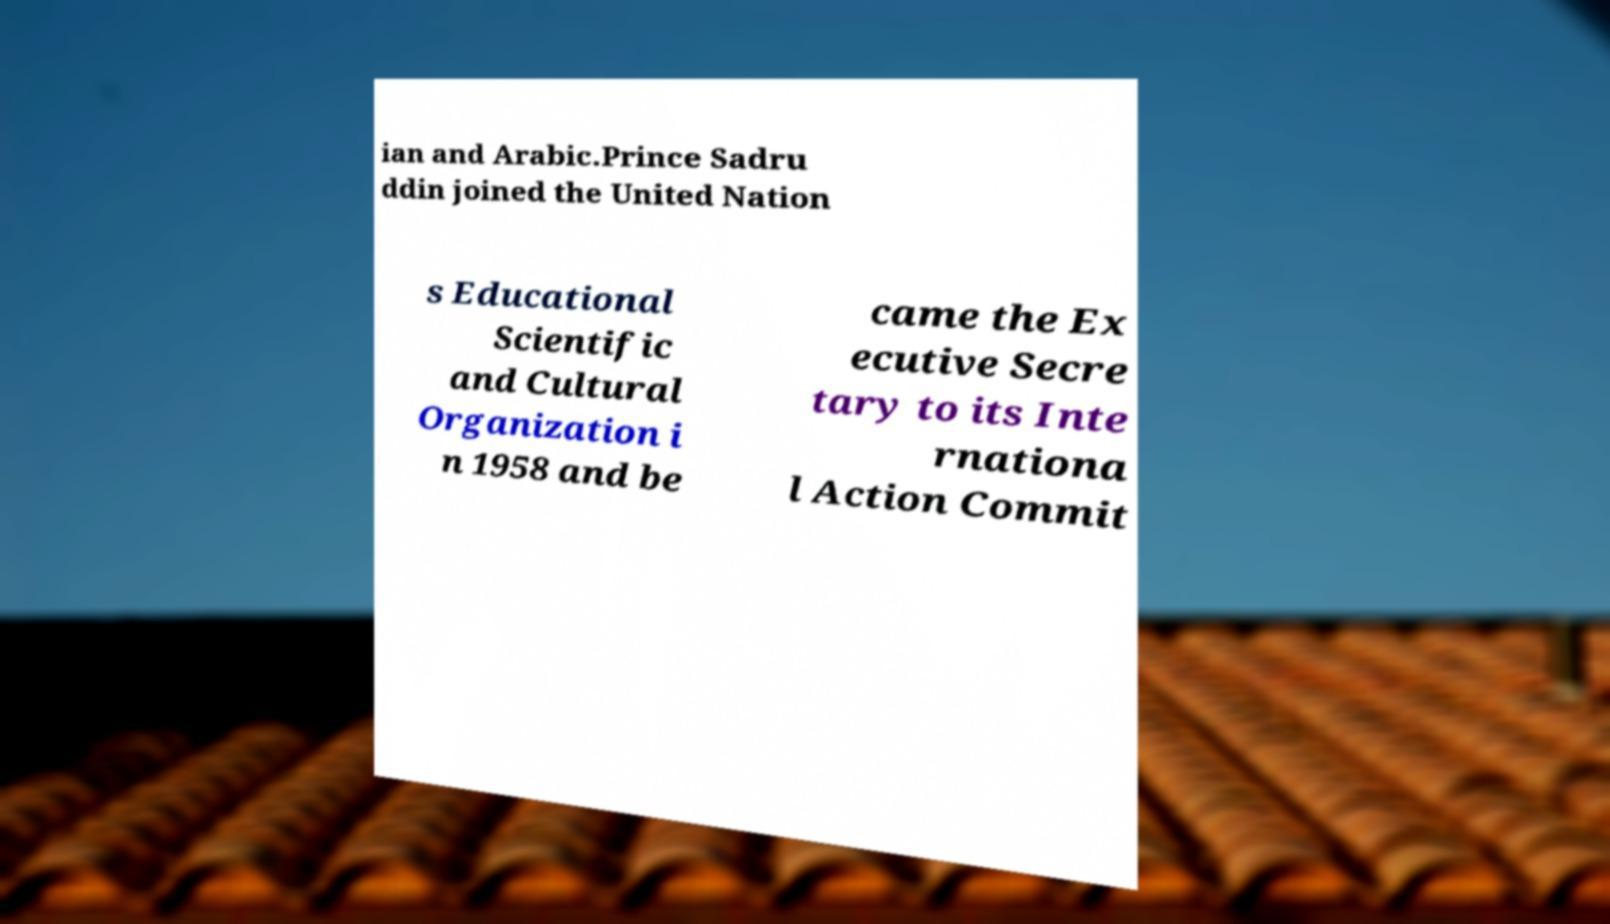For documentation purposes, I need the text within this image transcribed. Could you provide that? ian and Arabic.Prince Sadru ddin joined the United Nation s Educational Scientific and Cultural Organization i n 1958 and be came the Ex ecutive Secre tary to its Inte rnationa l Action Commit 